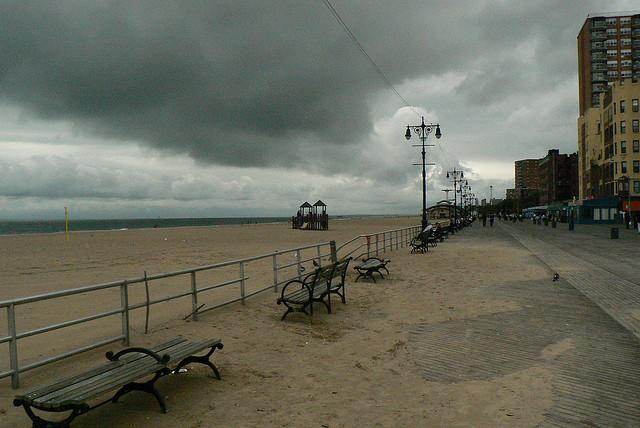Why is the beach empty? storm coming 